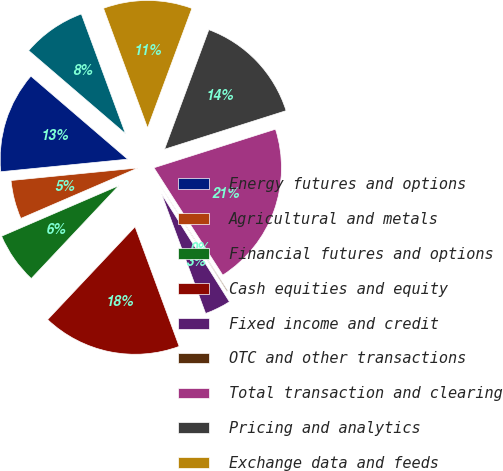<chart> <loc_0><loc_0><loc_500><loc_500><pie_chart><fcel>Energy futures and options<fcel>Agricultural and metals<fcel>Financial futures and options<fcel>Cash equities and equity<fcel>Fixed income and credit<fcel>OTC and other transactions<fcel>Total transaction and clearing<fcel>Pricing and analytics<fcel>Exchange data and feeds<fcel>Desktops and connectivity<nl><fcel>12.86%<fcel>4.91%<fcel>6.5%<fcel>17.64%<fcel>3.32%<fcel>0.13%<fcel>20.82%<fcel>14.46%<fcel>11.27%<fcel>8.09%<nl></chart> 